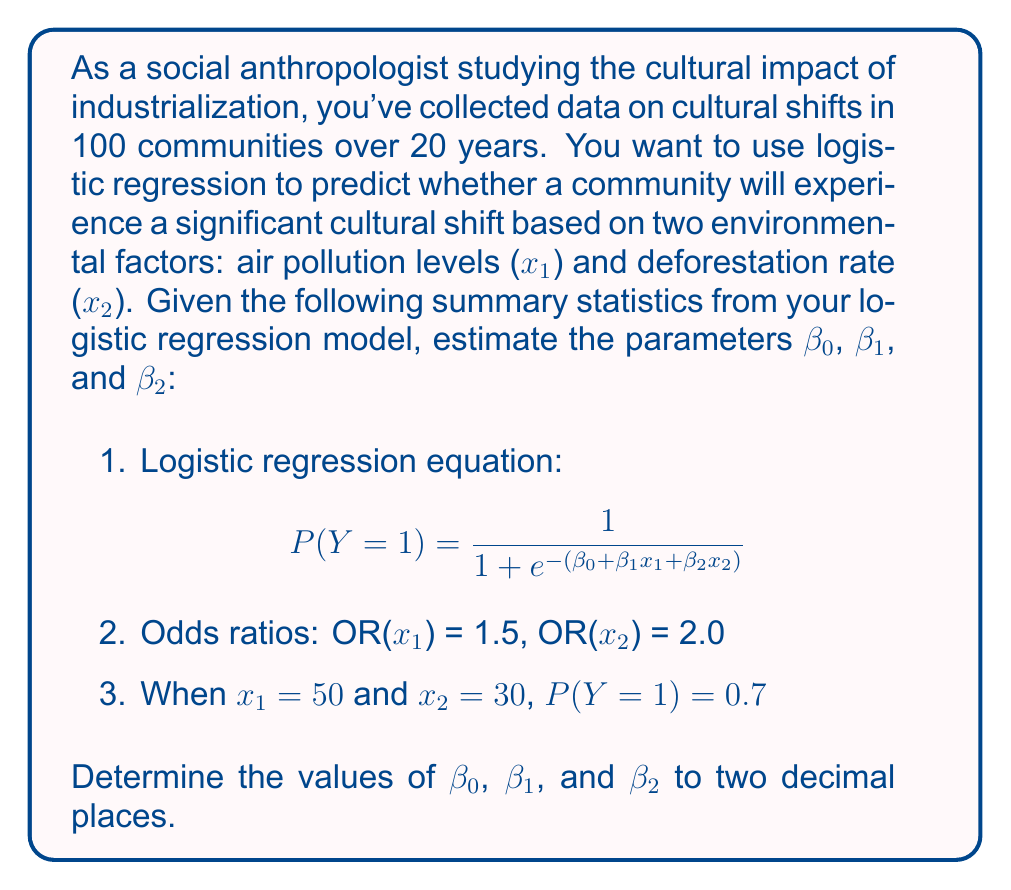Help me with this question. Let's approach this step-by-step:

1) First, we know that for logistic regression, the odds ratio for a variable is equal to e raised to the power of its coefficient. So:

   $e^{\beta_1} = 1.5$ and $e^{\beta_2} = 2.0$

2) Taking the natural log of both sides:

   $\beta_1 = \ln(1.5) \approx 0.4055$
   $\beta_2 = \ln(2.0) \approx 0.6931$

3) Now, we can use the given probability when x₁ = 50 and x₂ = 30 to find β₀:

   $0.7 = \frac{1}{1 + e^{-(\beta_0 + 0.4055(50) + 0.6931(30))}}$

4) Let's solve this equation for β₀:

   $\frac{1}{0.7} = 1 + e^{-(\beta_0 + 20.275 + 20.793)}$
   $1.4286 = 1 + e^{-(\beta_0 + 41.068)}$
   $0.4286 = e^{-(\beta_0 + 41.068)}$
   $\ln(0.4286) = -(\beta_0 + 41.068)$
   $-0.8473 = -(\beta_0 + 41.068)$
   $\beta_0 = -41.068 + 0.8473 = -40.2207$

5) Rounding to two decimal places:

   $\beta_0 \approx -40.22$
   $\beta_1 \approx 0.41$
   $\beta_2 \approx 0.69$
Answer: $\beta_0 = -40.22, \beta_1 = 0.41, \beta_2 = 0.69$ 